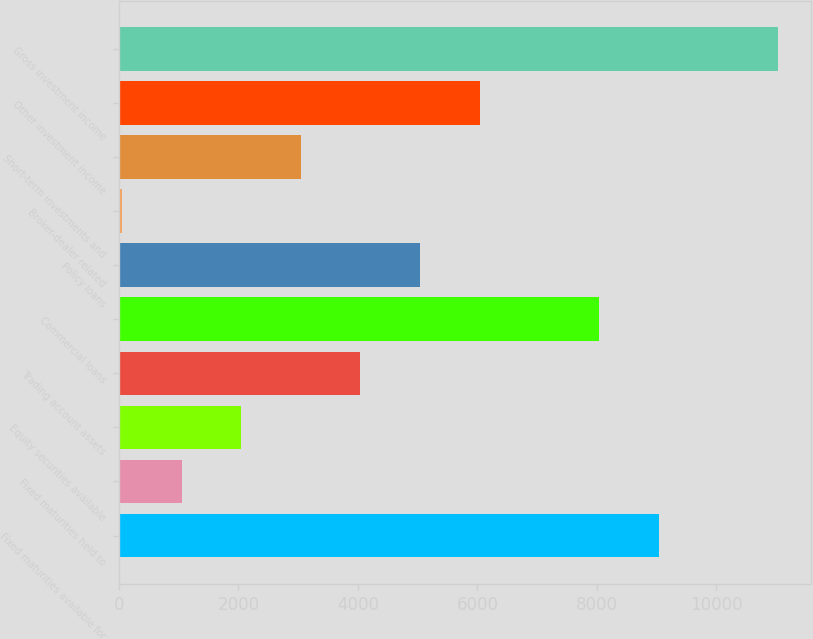Convert chart to OTSL. <chart><loc_0><loc_0><loc_500><loc_500><bar_chart><fcel>Fixed maturities available for<fcel>Fixed maturities held to<fcel>Equity securities available<fcel>Trading account assets<fcel>Commercial loans<fcel>Policy loans<fcel>Broker-dealer related<fcel>Short-term investments and<fcel>Other investment income<fcel>Gross investment income<nl><fcel>9030.4<fcel>1049.6<fcel>2047.2<fcel>4042.4<fcel>8032.8<fcel>5040<fcel>52<fcel>3044.8<fcel>6037.6<fcel>11025.6<nl></chart> 